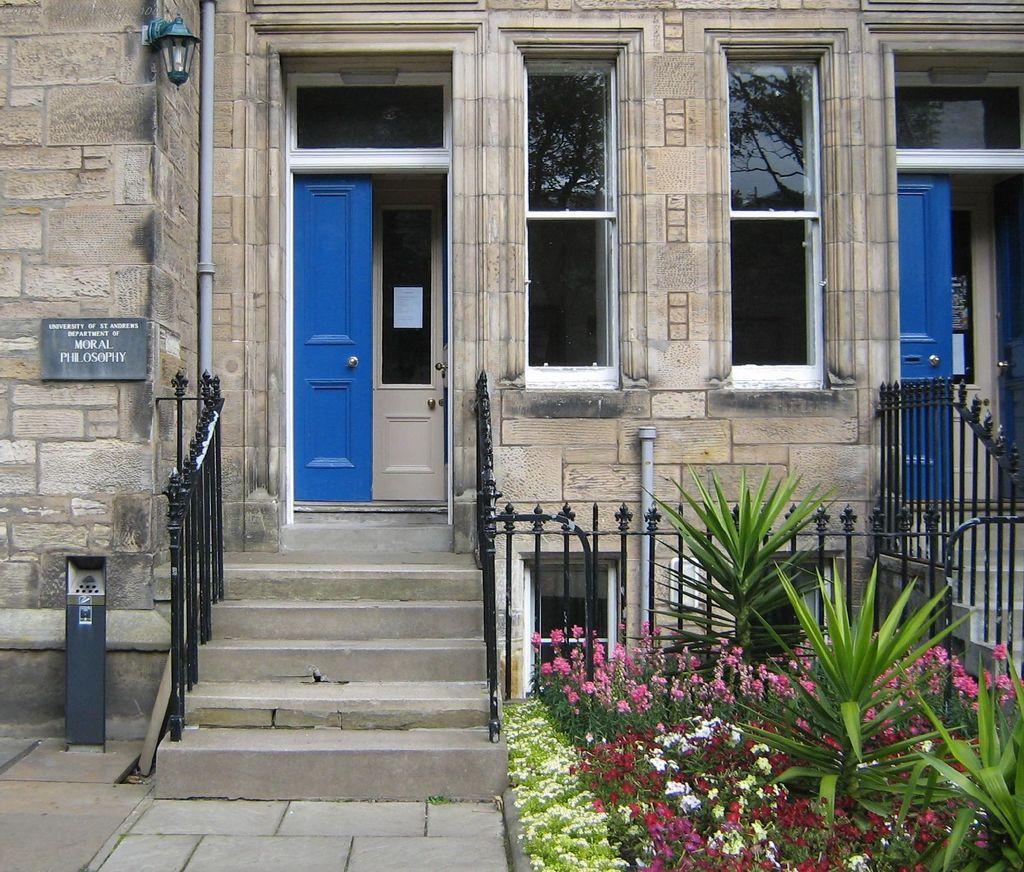Describe this image in one or two sentences. In the image I can see a house to which there is a door, board, fencing and also I can see some plants. 